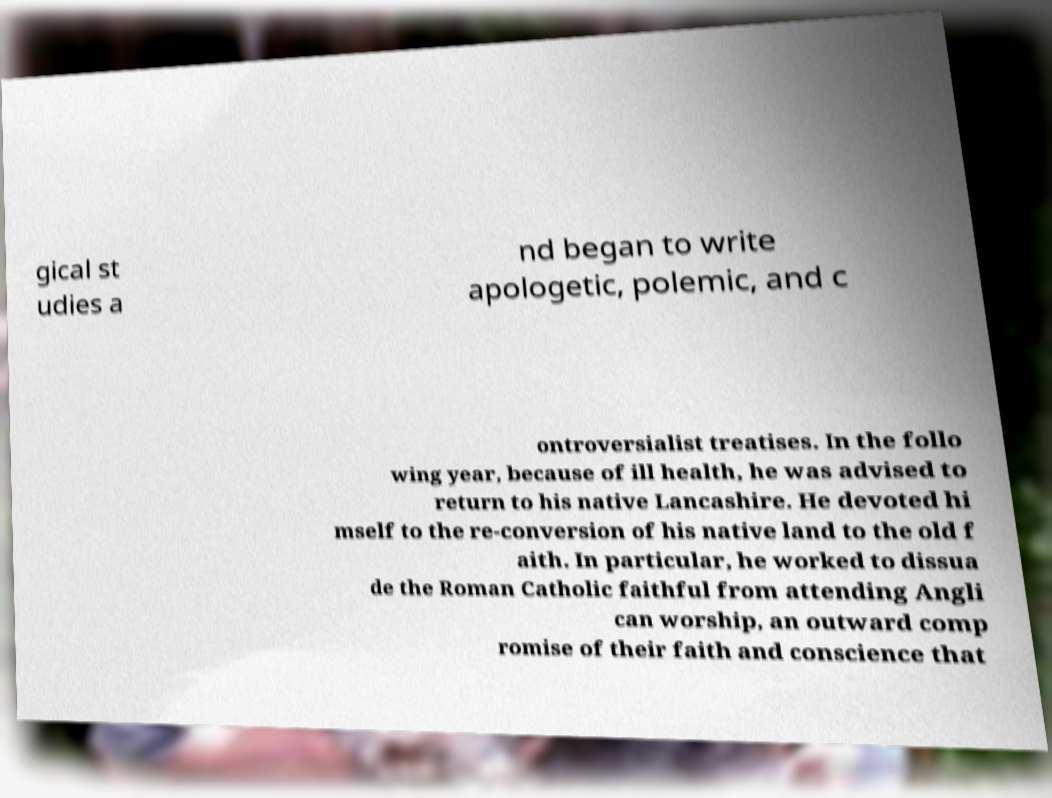For documentation purposes, I need the text within this image transcribed. Could you provide that? gical st udies a nd began to write apologetic, polemic, and c ontroversialist treatises. In the follo wing year, because of ill health, he was advised to return to his native Lancashire. He devoted hi mself to the re-conversion of his native land to the old f aith. In particular, he worked to dissua de the Roman Catholic faithful from attending Angli can worship, an outward comp romise of their faith and conscience that 